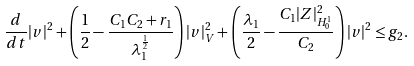Convert formula to latex. <formula><loc_0><loc_0><loc_500><loc_500>\frac { d } { d t } | v | ^ { 2 } + \left ( \frac { 1 } { 2 } - \frac { C _ { 1 } C _ { 2 } + r _ { 1 } } { \lambda _ { 1 } ^ { \frac { 1 } { 2 } } } \right ) | v | _ { V } ^ { 2 } + \left ( \frac { \lambda _ { 1 } } { 2 } - \frac { C _ { 1 } | Z | _ { H _ { 0 } ^ { 1 } } ^ { 2 } } { C _ { 2 } } \right ) | v | ^ { 2 } \leq g _ { 2 } .</formula> 